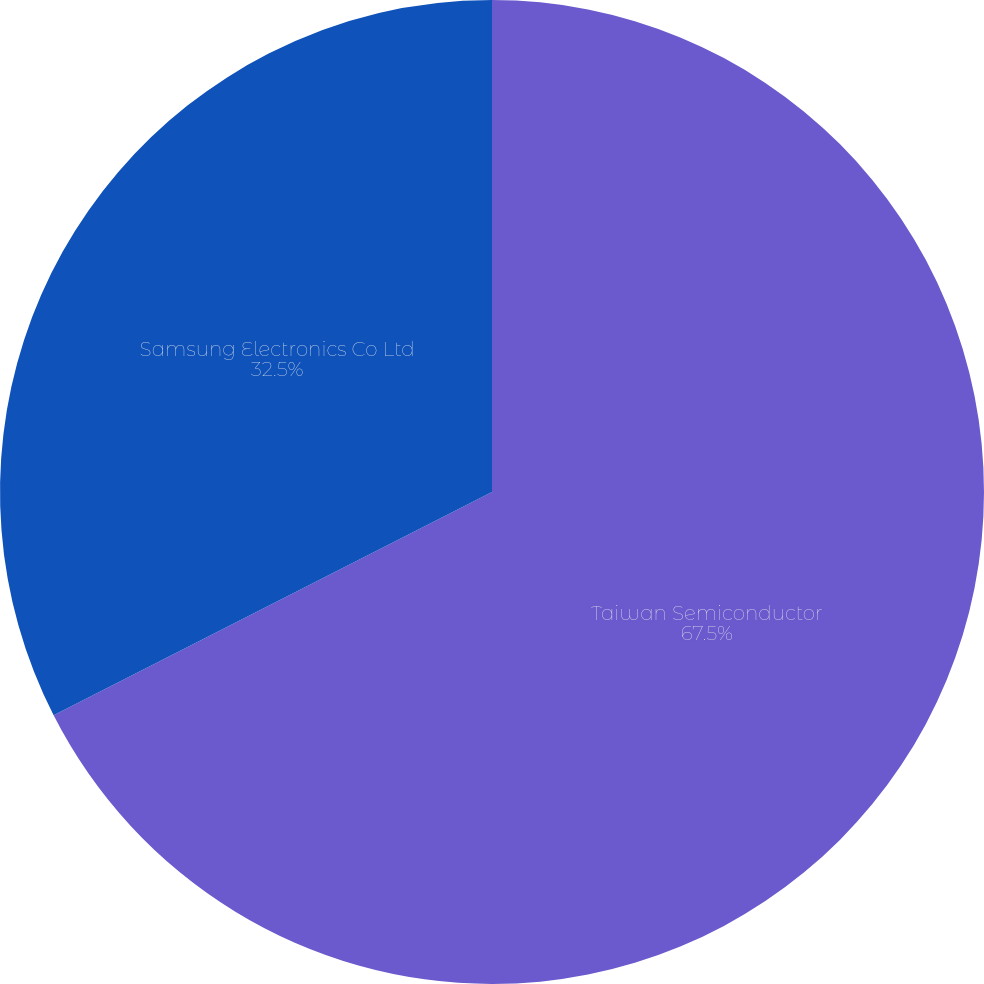Convert chart. <chart><loc_0><loc_0><loc_500><loc_500><pie_chart><fcel>Taiwan Semiconductor<fcel>Samsung Electronics Co Ltd<nl><fcel>67.5%<fcel>32.5%<nl></chart> 